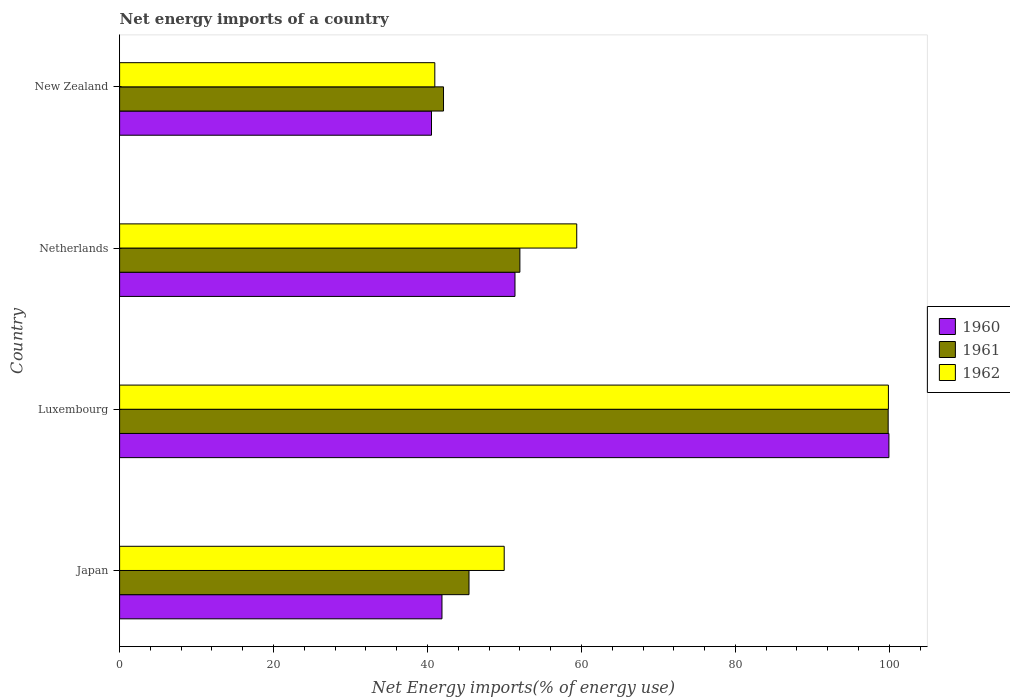How many different coloured bars are there?
Make the answer very short. 3. How many groups of bars are there?
Ensure brevity in your answer.  4. Are the number of bars per tick equal to the number of legend labels?
Keep it short and to the point. Yes. Are the number of bars on each tick of the Y-axis equal?
Ensure brevity in your answer.  Yes. How many bars are there on the 3rd tick from the top?
Your answer should be very brief. 3. What is the net energy imports in 1961 in New Zealand?
Your answer should be very brief. 42.08. Across all countries, what is the maximum net energy imports in 1962?
Offer a very short reply. 99.88. Across all countries, what is the minimum net energy imports in 1961?
Provide a short and direct response. 42.08. In which country was the net energy imports in 1961 maximum?
Your response must be concise. Luxembourg. In which country was the net energy imports in 1961 minimum?
Ensure brevity in your answer.  New Zealand. What is the total net energy imports in 1960 in the graph?
Offer a very short reply. 233.72. What is the difference between the net energy imports in 1961 in Luxembourg and that in New Zealand?
Make the answer very short. 57.77. What is the difference between the net energy imports in 1960 in Japan and the net energy imports in 1961 in Luxembourg?
Your response must be concise. -57.97. What is the average net energy imports in 1960 per country?
Your answer should be compact. 58.43. What is the difference between the net energy imports in 1962 and net energy imports in 1960 in Netherlands?
Your answer should be compact. 8.02. What is the ratio of the net energy imports in 1960 in Japan to that in Luxembourg?
Your answer should be very brief. 0.42. Is the net energy imports in 1962 in Japan less than that in Netherlands?
Make the answer very short. Yes. Is the difference between the net energy imports in 1962 in Japan and New Zealand greater than the difference between the net energy imports in 1960 in Japan and New Zealand?
Offer a terse response. Yes. What is the difference between the highest and the second highest net energy imports in 1961?
Your response must be concise. 47.85. What is the difference between the highest and the lowest net energy imports in 1962?
Your answer should be compact. 58.93. Is the sum of the net energy imports in 1960 in Netherlands and New Zealand greater than the maximum net energy imports in 1961 across all countries?
Offer a terse response. No. What does the 2nd bar from the top in Japan represents?
Offer a very short reply. 1961. What does the 2nd bar from the bottom in Luxembourg represents?
Offer a very short reply. 1961. How many bars are there?
Your response must be concise. 12. Are all the bars in the graph horizontal?
Your answer should be very brief. Yes. How many countries are there in the graph?
Make the answer very short. 4. Does the graph contain any zero values?
Provide a short and direct response. No. What is the title of the graph?
Your response must be concise. Net energy imports of a country. Does "2006" appear as one of the legend labels in the graph?
Offer a very short reply. No. What is the label or title of the X-axis?
Provide a short and direct response. Net Energy imports(% of energy use). What is the Net Energy imports(% of energy use) in 1960 in Japan?
Your answer should be very brief. 41.88. What is the Net Energy imports(% of energy use) in 1961 in Japan?
Give a very brief answer. 45.39. What is the Net Energy imports(% of energy use) of 1962 in Japan?
Keep it short and to the point. 49.97. What is the Net Energy imports(% of energy use) of 1960 in Luxembourg?
Offer a very short reply. 99.95. What is the Net Energy imports(% of energy use) in 1961 in Luxembourg?
Provide a succinct answer. 99.85. What is the Net Energy imports(% of energy use) of 1962 in Luxembourg?
Your answer should be very brief. 99.88. What is the Net Energy imports(% of energy use) of 1960 in Netherlands?
Provide a succinct answer. 51.37. What is the Net Energy imports(% of energy use) of 1961 in Netherlands?
Provide a succinct answer. 52. What is the Net Energy imports(% of energy use) in 1962 in Netherlands?
Provide a succinct answer. 59.39. What is the Net Energy imports(% of energy use) in 1960 in New Zealand?
Give a very brief answer. 40.52. What is the Net Energy imports(% of energy use) in 1961 in New Zealand?
Provide a short and direct response. 42.08. What is the Net Energy imports(% of energy use) of 1962 in New Zealand?
Make the answer very short. 40.95. Across all countries, what is the maximum Net Energy imports(% of energy use) of 1960?
Your response must be concise. 99.95. Across all countries, what is the maximum Net Energy imports(% of energy use) of 1961?
Make the answer very short. 99.85. Across all countries, what is the maximum Net Energy imports(% of energy use) in 1962?
Provide a short and direct response. 99.88. Across all countries, what is the minimum Net Energy imports(% of energy use) in 1960?
Your answer should be very brief. 40.52. Across all countries, what is the minimum Net Energy imports(% of energy use) in 1961?
Make the answer very short. 42.08. Across all countries, what is the minimum Net Energy imports(% of energy use) in 1962?
Make the answer very short. 40.95. What is the total Net Energy imports(% of energy use) of 1960 in the graph?
Provide a succinct answer. 233.72. What is the total Net Energy imports(% of energy use) of 1961 in the graph?
Make the answer very short. 239.34. What is the total Net Energy imports(% of energy use) of 1962 in the graph?
Keep it short and to the point. 250.2. What is the difference between the Net Energy imports(% of energy use) of 1960 in Japan and that in Luxembourg?
Your response must be concise. -58.07. What is the difference between the Net Energy imports(% of energy use) in 1961 in Japan and that in Luxembourg?
Give a very brief answer. -54.46. What is the difference between the Net Energy imports(% of energy use) of 1962 in Japan and that in Luxembourg?
Give a very brief answer. -49.92. What is the difference between the Net Energy imports(% of energy use) in 1960 in Japan and that in Netherlands?
Provide a short and direct response. -9.49. What is the difference between the Net Energy imports(% of energy use) of 1961 in Japan and that in Netherlands?
Ensure brevity in your answer.  -6.61. What is the difference between the Net Energy imports(% of energy use) in 1962 in Japan and that in Netherlands?
Keep it short and to the point. -9.42. What is the difference between the Net Energy imports(% of energy use) of 1960 in Japan and that in New Zealand?
Offer a terse response. 1.36. What is the difference between the Net Energy imports(% of energy use) in 1961 in Japan and that in New Zealand?
Provide a short and direct response. 3.31. What is the difference between the Net Energy imports(% of energy use) of 1962 in Japan and that in New Zealand?
Make the answer very short. 9.02. What is the difference between the Net Energy imports(% of energy use) of 1960 in Luxembourg and that in Netherlands?
Provide a short and direct response. 48.58. What is the difference between the Net Energy imports(% of energy use) of 1961 in Luxembourg and that in Netherlands?
Offer a very short reply. 47.85. What is the difference between the Net Energy imports(% of energy use) in 1962 in Luxembourg and that in Netherlands?
Your answer should be compact. 40.49. What is the difference between the Net Energy imports(% of energy use) in 1960 in Luxembourg and that in New Zealand?
Provide a short and direct response. 59.43. What is the difference between the Net Energy imports(% of energy use) of 1961 in Luxembourg and that in New Zealand?
Keep it short and to the point. 57.77. What is the difference between the Net Energy imports(% of energy use) of 1962 in Luxembourg and that in New Zealand?
Your answer should be very brief. 58.93. What is the difference between the Net Energy imports(% of energy use) of 1960 in Netherlands and that in New Zealand?
Provide a short and direct response. 10.85. What is the difference between the Net Energy imports(% of energy use) of 1961 in Netherlands and that in New Zealand?
Your answer should be compact. 9.92. What is the difference between the Net Energy imports(% of energy use) in 1962 in Netherlands and that in New Zealand?
Your answer should be compact. 18.44. What is the difference between the Net Energy imports(% of energy use) in 1960 in Japan and the Net Energy imports(% of energy use) in 1961 in Luxembourg?
Make the answer very short. -57.97. What is the difference between the Net Energy imports(% of energy use) in 1960 in Japan and the Net Energy imports(% of energy use) in 1962 in Luxembourg?
Your answer should be compact. -58. What is the difference between the Net Energy imports(% of energy use) in 1961 in Japan and the Net Energy imports(% of energy use) in 1962 in Luxembourg?
Your response must be concise. -54.49. What is the difference between the Net Energy imports(% of energy use) in 1960 in Japan and the Net Energy imports(% of energy use) in 1961 in Netherlands?
Provide a succinct answer. -10.12. What is the difference between the Net Energy imports(% of energy use) in 1960 in Japan and the Net Energy imports(% of energy use) in 1962 in Netherlands?
Keep it short and to the point. -17.51. What is the difference between the Net Energy imports(% of energy use) of 1961 in Japan and the Net Energy imports(% of energy use) of 1962 in Netherlands?
Provide a succinct answer. -14. What is the difference between the Net Energy imports(% of energy use) of 1960 in Japan and the Net Energy imports(% of energy use) of 1961 in New Zealand?
Provide a succinct answer. -0.2. What is the difference between the Net Energy imports(% of energy use) of 1960 in Japan and the Net Energy imports(% of energy use) of 1962 in New Zealand?
Keep it short and to the point. 0.93. What is the difference between the Net Energy imports(% of energy use) of 1961 in Japan and the Net Energy imports(% of energy use) of 1962 in New Zealand?
Offer a very short reply. 4.44. What is the difference between the Net Energy imports(% of energy use) in 1960 in Luxembourg and the Net Energy imports(% of energy use) in 1961 in Netherlands?
Your response must be concise. 47.94. What is the difference between the Net Energy imports(% of energy use) of 1960 in Luxembourg and the Net Energy imports(% of energy use) of 1962 in Netherlands?
Provide a short and direct response. 40.56. What is the difference between the Net Energy imports(% of energy use) of 1961 in Luxembourg and the Net Energy imports(% of energy use) of 1962 in Netherlands?
Your response must be concise. 40.46. What is the difference between the Net Energy imports(% of energy use) of 1960 in Luxembourg and the Net Energy imports(% of energy use) of 1961 in New Zealand?
Offer a very short reply. 57.87. What is the difference between the Net Energy imports(% of energy use) in 1960 in Luxembourg and the Net Energy imports(% of energy use) in 1962 in New Zealand?
Your answer should be very brief. 58.99. What is the difference between the Net Energy imports(% of energy use) in 1961 in Luxembourg and the Net Energy imports(% of energy use) in 1962 in New Zealand?
Provide a succinct answer. 58.9. What is the difference between the Net Energy imports(% of energy use) in 1960 in Netherlands and the Net Energy imports(% of energy use) in 1961 in New Zealand?
Offer a terse response. 9.29. What is the difference between the Net Energy imports(% of energy use) of 1960 in Netherlands and the Net Energy imports(% of energy use) of 1962 in New Zealand?
Give a very brief answer. 10.42. What is the difference between the Net Energy imports(% of energy use) in 1961 in Netherlands and the Net Energy imports(% of energy use) in 1962 in New Zealand?
Your answer should be very brief. 11.05. What is the average Net Energy imports(% of energy use) in 1960 per country?
Give a very brief answer. 58.43. What is the average Net Energy imports(% of energy use) in 1961 per country?
Keep it short and to the point. 59.83. What is the average Net Energy imports(% of energy use) in 1962 per country?
Your answer should be compact. 62.55. What is the difference between the Net Energy imports(% of energy use) of 1960 and Net Energy imports(% of energy use) of 1961 in Japan?
Your answer should be compact. -3.51. What is the difference between the Net Energy imports(% of energy use) of 1960 and Net Energy imports(% of energy use) of 1962 in Japan?
Your answer should be very brief. -8.09. What is the difference between the Net Energy imports(% of energy use) in 1961 and Net Energy imports(% of energy use) in 1962 in Japan?
Provide a short and direct response. -4.57. What is the difference between the Net Energy imports(% of energy use) in 1960 and Net Energy imports(% of energy use) in 1961 in Luxembourg?
Your answer should be compact. 0.09. What is the difference between the Net Energy imports(% of energy use) in 1960 and Net Energy imports(% of energy use) in 1962 in Luxembourg?
Your answer should be compact. 0.06. What is the difference between the Net Energy imports(% of energy use) in 1961 and Net Energy imports(% of energy use) in 1962 in Luxembourg?
Ensure brevity in your answer.  -0.03. What is the difference between the Net Energy imports(% of energy use) in 1960 and Net Energy imports(% of energy use) in 1961 in Netherlands?
Ensure brevity in your answer.  -0.64. What is the difference between the Net Energy imports(% of energy use) in 1960 and Net Energy imports(% of energy use) in 1962 in Netherlands?
Make the answer very short. -8.02. What is the difference between the Net Energy imports(% of energy use) of 1961 and Net Energy imports(% of energy use) of 1962 in Netherlands?
Your answer should be compact. -7.39. What is the difference between the Net Energy imports(% of energy use) in 1960 and Net Energy imports(% of energy use) in 1961 in New Zealand?
Keep it short and to the point. -1.56. What is the difference between the Net Energy imports(% of energy use) in 1960 and Net Energy imports(% of energy use) in 1962 in New Zealand?
Make the answer very short. -0.43. What is the difference between the Net Energy imports(% of energy use) of 1961 and Net Energy imports(% of energy use) of 1962 in New Zealand?
Your answer should be very brief. 1.13. What is the ratio of the Net Energy imports(% of energy use) in 1960 in Japan to that in Luxembourg?
Your answer should be compact. 0.42. What is the ratio of the Net Energy imports(% of energy use) of 1961 in Japan to that in Luxembourg?
Provide a short and direct response. 0.45. What is the ratio of the Net Energy imports(% of energy use) of 1962 in Japan to that in Luxembourg?
Offer a terse response. 0.5. What is the ratio of the Net Energy imports(% of energy use) in 1960 in Japan to that in Netherlands?
Your response must be concise. 0.82. What is the ratio of the Net Energy imports(% of energy use) in 1961 in Japan to that in Netherlands?
Make the answer very short. 0.87. What is the ratio of the Net Energy imports(% of energy use) in 1962 in Japan to that in Netherlands?
Offer a terse response. 0.84. What is the ratio of the Net Energy imports(% of energy use) in 1960 in Japan to that in New Zealand?
Your response must be concise. 1.03. What is the ratio of the Net Energy imports(% of energy use) in 1961 in Japan to that in New Zealand?
Make the answer very short. 1.08. What is the ratio of the Net Energy imports(% of energy use) in 1962 in Japan to that in New Zealand?
Give a very brief answer. 1.22. What is the ratio of the Net Energy imports(% of energy use) of 1960 in Luxembourg to that in Netherlands?
Your answer should be compact. 1.95. What is the ratio of the Net Energy imports(% of energy use) of 1961 in Luxembourg to that in Netherlands?
Keep it short and to the point. 1.92. What is the ratio of the Net Energy imports(% of energy use) in 1962 in Luxembourg to that in Netherlands?
Offer a very short reply. 1.68. What is the ratio of the Net Energy imports(% of energy use) in 1960 in Luxembourg to that in New Zealand?
Your answer should be compact. 2.47. What is the ratio of the Net Energy imports(% of energy use) of 1961 in Luxembourg to that in New Zealand?
Give a very brief answer. 2.37. What is the ratio of the Net Energy imports(% of energy use) of 1962 in Luxembourg to that in New Zealand?
Your answer should be compact. 2.44. What is the ratio of the Net Energy imports(% of energy use) of 1960 in Netherlands to that in New Zealand?
Your answer should be very brief. 1.27. What is the ratio of the Net Energy imports(% of energy use) in 1961 in Netherlands to that in New Zealand?
Keep it short and to the point. 1.24. What is the ratio of the Net Energy imports(% of energy use) in 1962 in Netherlands to that in New Zealand?
Provide a short and direct response. 1.45. What is the difference between the highest and the second highest Net Energy imports(% of energy use) of 1960?
Offer a terse response. 48.58. What is the difference between the highest and the second highest Net Energy imports(% of energy use) in 1961?
Provide a short and direct response. 47.85. What is the difference between the highest and the second highest Net Energy imports(% of energy use) of 1962?
Provide a short and direct response. 40.49. What is the difference between the highest and the lowest Net Energy imports(% of energy use) in 1960?
Your response must be concise. 59.43. What is the difference between the highest and the lowest Net Energy imports(% of energy use) of 1961?
Your answer should be compact. 57.77. What is the difference between the highest and the lowest Net Energy imports(% of energy use) of 1962?
Offer a terse response. 58.93. 